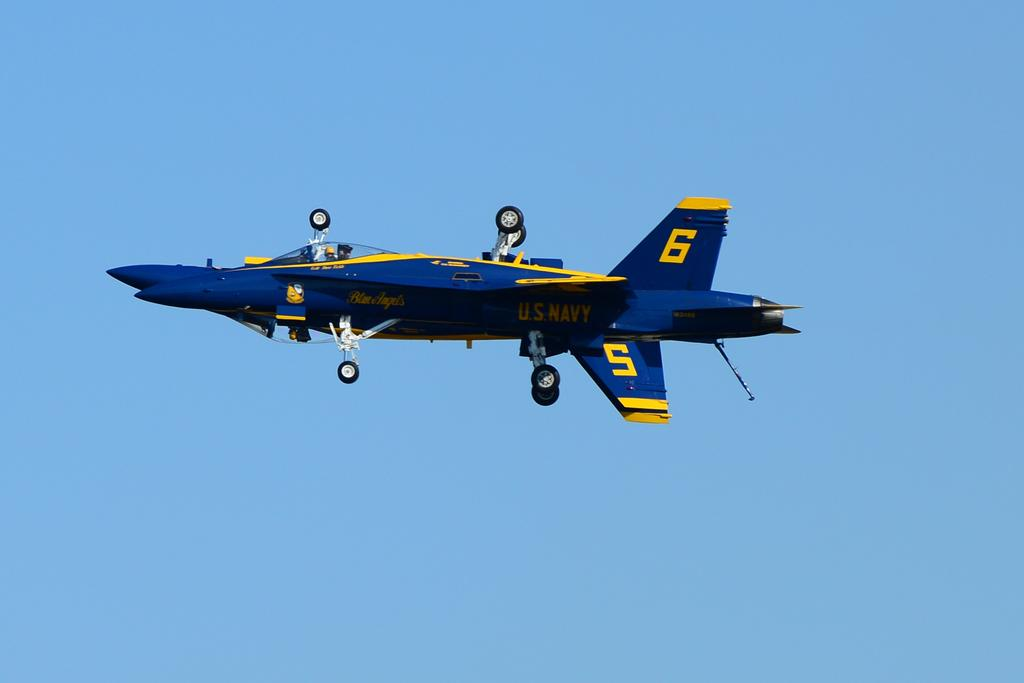<image>
Present a compact description of the photo's key features. a blue plane flying with the number 6 on the tail 